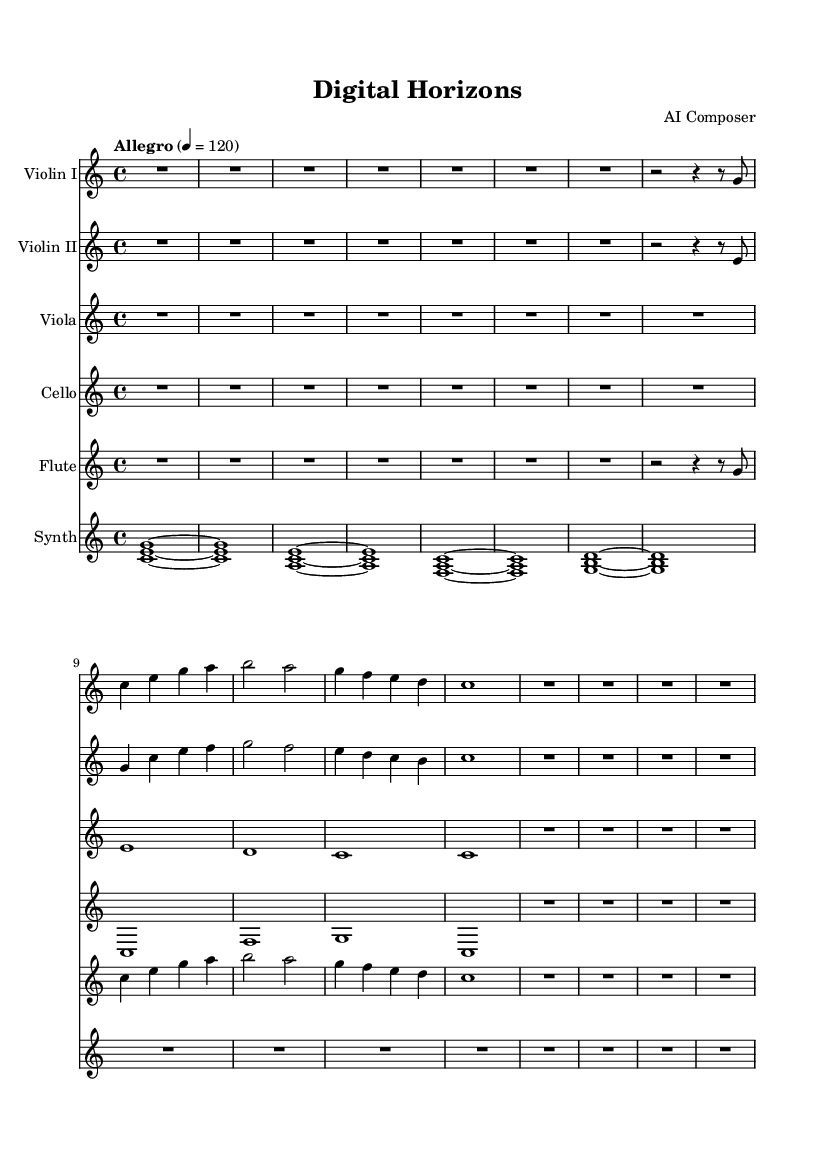What is the key signature of this music? The key signature is C major, which has no sharps or flats indicated at the beginning of the staff.
Answer: C major What is the time signature of this symphony? The time signature is found at the start of the score, indicated as 4/4, meaning four beats per measure.
Answer: 4/4 What is the tempo marking for this piece? The tempo marking is specified at the beginning as "Allegro," with a metronome marking of 120 beats per minute.
Answer: Allegro How many instruments are featured in this score? The score lists six different staves for instruments: Violin I, Violin II, Viola, Cello, Flute, and Synthesizer, resulting in a total of six instruments.
Answer: Six What is the role of the synthesizer in this symphony? The synthesizer plays sustained chords and harmonic support throughout the piece, evident from the use of held notes and emphasis on harmony.
Answer: Harmonic support Which instruments are playing the first melodic line? The first melodic line is introduced by Violin I and Flute, as they both play similar rhythm and pitch patterns at the start.
Answer: Violin I and Flute What unique element is incorporated into this contemporary symphony? The incorporation of electronic elements and digital sounds is highlighted by the use of the synthesizer, distinguishing it from traditional symphonies.
Answer: Electronic elements 